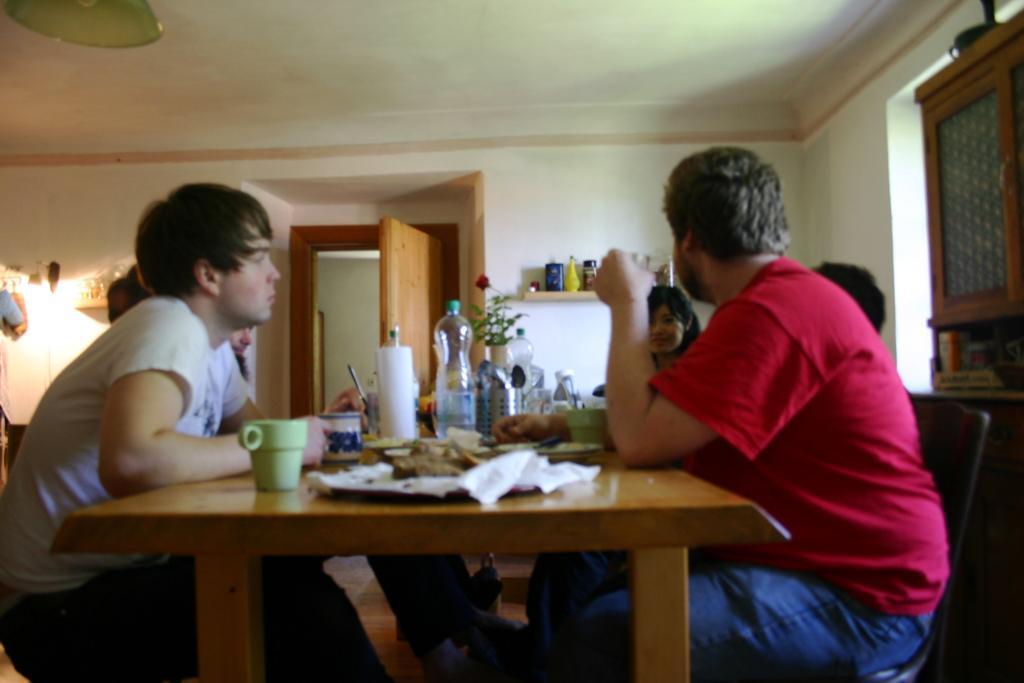Describe this image in one or two sentences. This picture describes about group of people, there are all seated in front of dining table, and we can find couple of bottles, cups, plates on the table. 